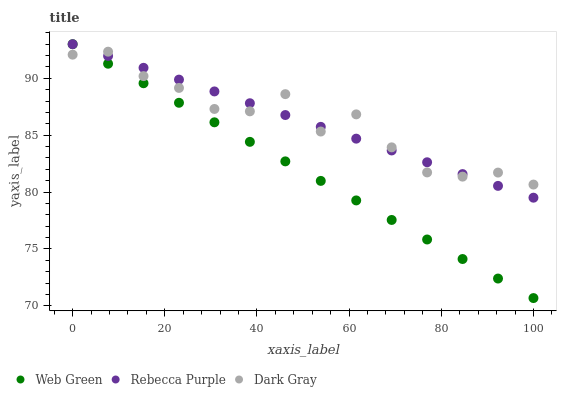Does Web Green have the minimum area under the curve?
Answer yes or no. Yes. Does Dark Gray have the maximum area under the curve?
Answer yes or no. Yes. Does Rebecca Purple have the minimum area under the curve?
Answer yes or no. No. Does Rebecca Purple have the maximum area under the curve?
Answer yes or no. No. Is Web Green the smoothest?
Answer yes or no. Yes. Is Dark Gray the roughest?
Answer yes or no. Yes. Is Rebecca Purple the smoothest?
Answer yes or no. No. Is Rebecca Purple the roughest?
Answer yes or no. No. Does Web Green have the lowest value?
Answer yes or no. Yes. Does Rebecca Purple have the lowest value?
Answer yes or no. No. Does Web Green have the highest value?
Answer yes or no. Yes. Does Web Green intersect Rebecca Purple?
Answer yes or no. Yes. Is Web Green less than Rebecca Purple?
Answer yes or no. No. Is Web Green greater than Rebecca Purple?
Answer yes or no. No. 